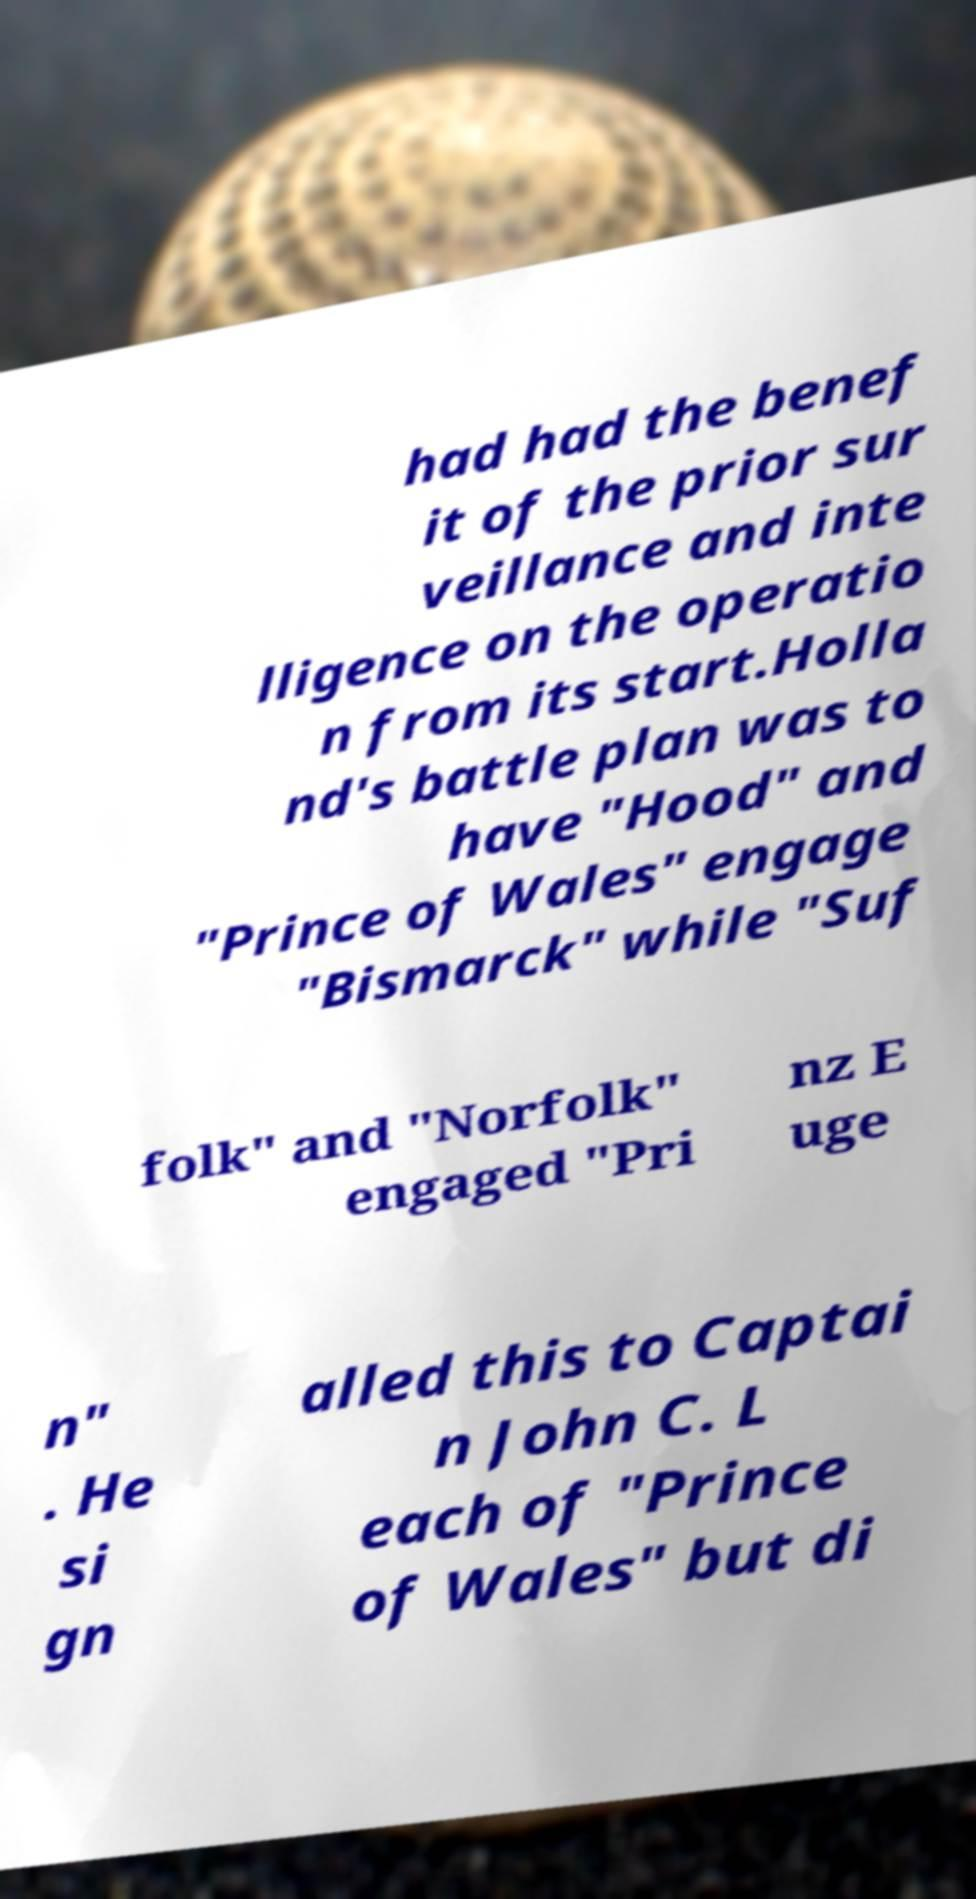Can you read and provide the text displayed in the image?This photo seems to have some interesting text. Can you extract and type it out for me? had had the benef it of the prior sur veillance and inte lligence on the operatio n from its start.Holla nd's battle plan was to have "Hood" and "Prince of Wales" engage "Bismarck" while "Suf folk" and "Norfolk" engaged "Pri nz E uge n" . He si gn alled this to Captai n John C. L each of "Prince of Wales" but di 